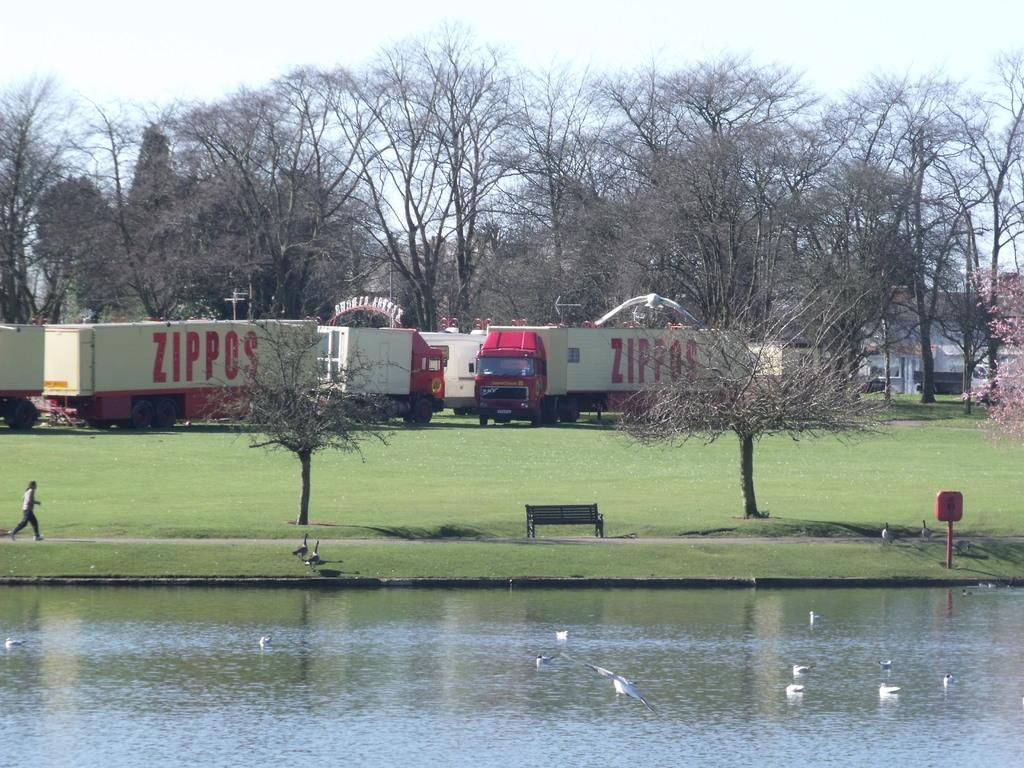What body of water is visible in the image? There is a pond in the image. What type of animals can be seen in the pond? Ducks are present in the pond. What vehicles are located on the grassland in the image? There are trucks on the grassland in the image. What type of vegetation can be seen in the background of the image? Trees are visible in the background of the image. What part of the natural environment is visible in the image? The sky is visible in the image. What type of powder is being used to clean the ducks in the image? There is no powder or cleaning activity involving the ducks in the image; they are simply swimming in the pond. 